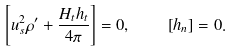Convert formula to latex. <formula><loc_0><loc_0><loc_500><loc_500>\left [ u _ { s } ^ { 2 } \rho ^ { \prime } + \frac { H _ { t } h _ { t } } { 4 \pi } \right ] = 0 , \quad \left [ h _ { n } \right ] = 0 .</formula> 